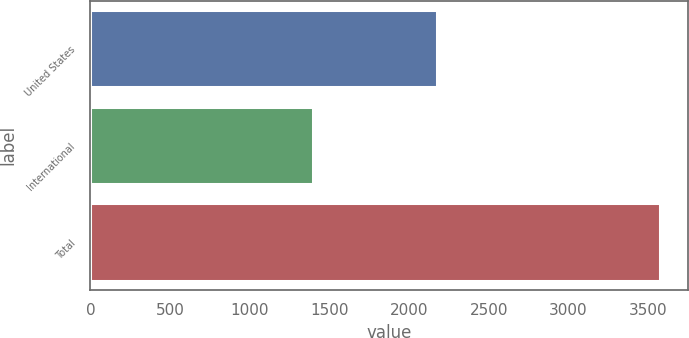Convert chart to OTSL. <chart><loc_0><loc_0><loc_500><loc_500><bar_chart><fcel>United States<fcel>International<fcel>Total<nl><fcel>2175<fcel>1397<fcel>3572<nl></chart> 